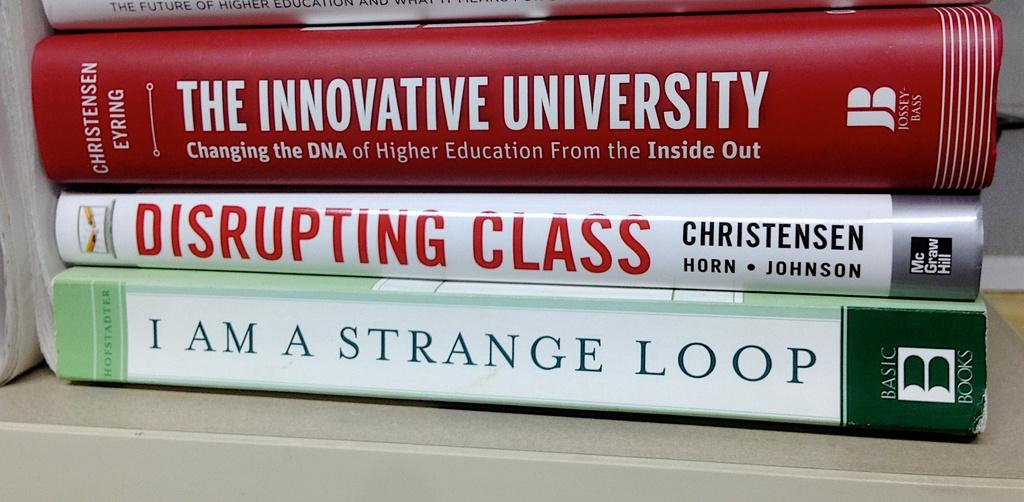<image>
Render a clear and concise summary of the photo. A stack of books, the bottom book reads, I am a strange loop. 